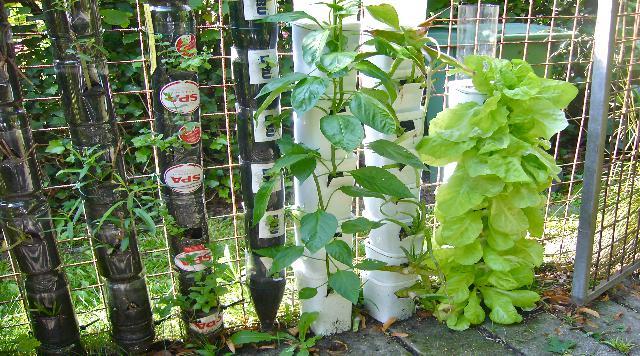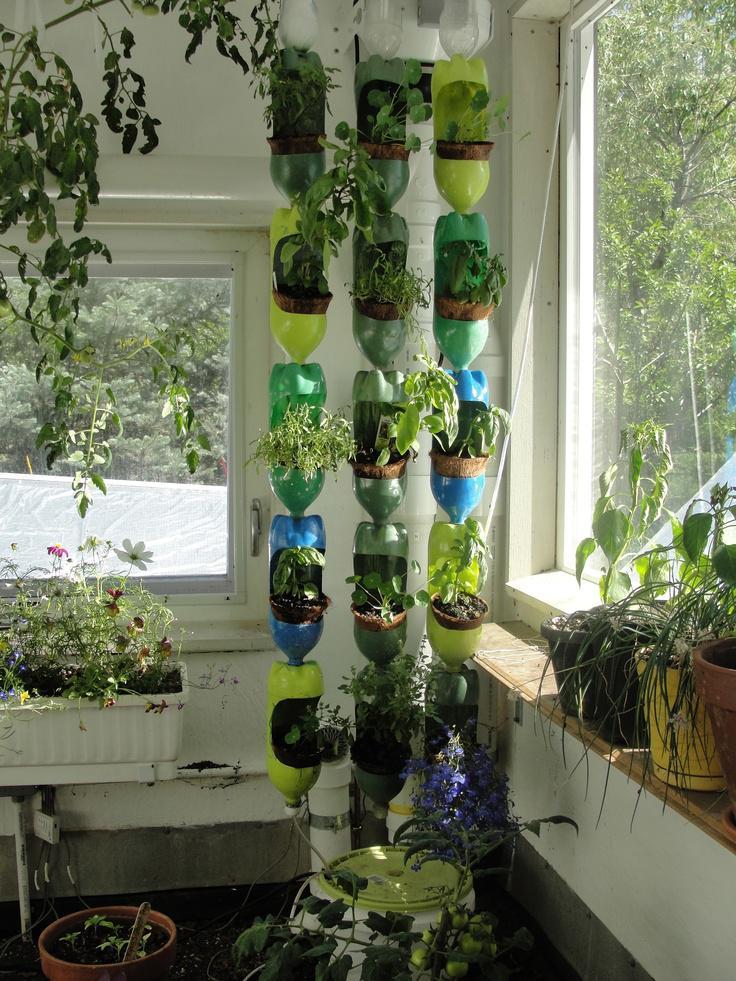The first image is the image on the left, the second image is the image on the right. Considering the images on both sides, is "One image shows a man in a blue shirt standing in front of two hanging orange planters and a row of cylinder shapes topped with up-ended plastic bottles." valid? Answer yes or no. No. The first image is the image on the left, the second image is the image on the right. For the images shown, is this caption "A man in a blue shirt is tending to a garden in the image on the right." true? Answer yes or no. No. 